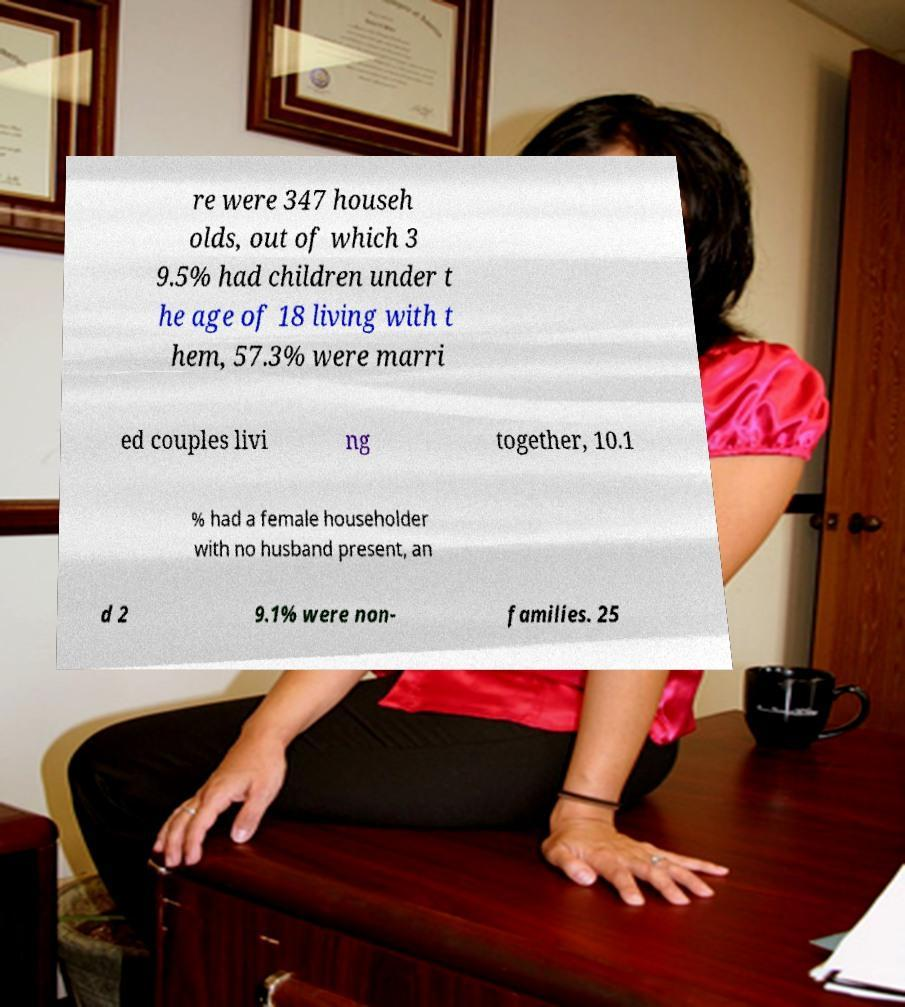Could you assist in decoding the text presented in this image and type it out clearly? re were 347 househ olds, out of which 3 9.5% had children under t he age of 18 living with t hem, 57.3% were marri ed couples livi ng together, 10.1 % had a female householder with no husband present, an d 2 9.1% were non- families. 25 